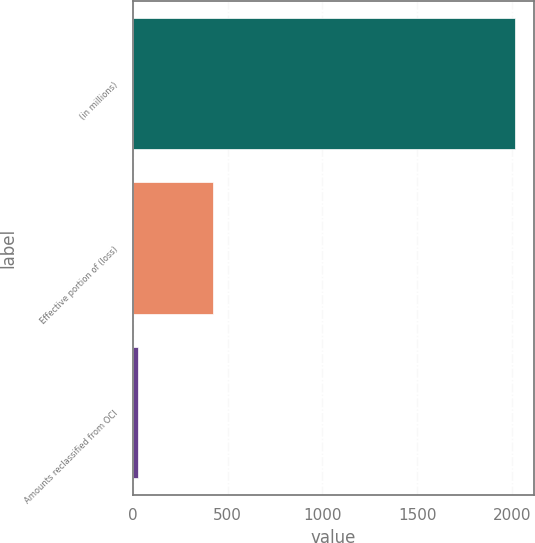Convert chart to OTSL. <chart><loc_0><loc_0><loc_500><loc_500><bar_chart><fcel>(in millions)<fcel>Effective portion of (loss)<fcel>Amounts reclassified from OCI<nl><fcel>2016<fcel>424.8<fcel>27<nl></chart> 